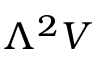Convert formula to latex. <formula><loc_0><loc_0><loc_500><loc_500>\Lambda ^ { 2 } V</formula> 